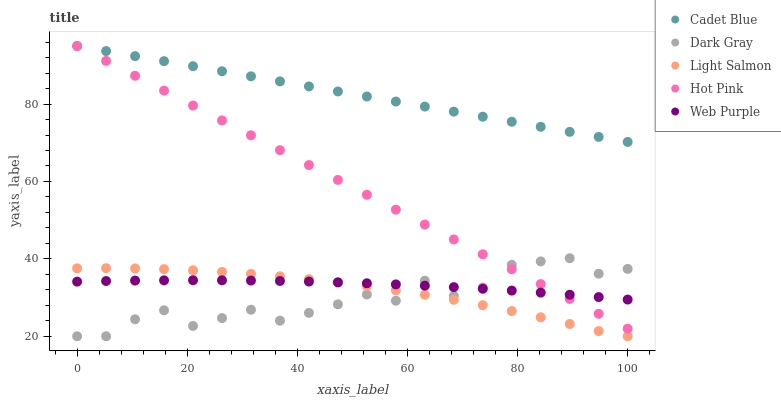Does Dark Gray have the minimum area under the curve?
Answer yes or no. Yes. Does Cadet Blue have the maximum area under the curve?
Answer yes or no. Yes. Does Light Salmon have the minimum area under the curve?
Answer yes or no. No. Does Light Salmon have the maximum area under the curve?
Answer yes or no. No. Is Hot Pink the smoothest?
Answer yes or no. Yes. Is Dark Gray the roughest?
Answer yes or no. Yes. Is Light Salmon the smoothest?
Answer yes or no. No. Is Light Salmon the roughest?
Answer yes or no. No. Does Dark Gray have the lowest value?
Answer yes or no. Yes. Does Cadet Blue have the lowest value?
Answer yes or no. No. Does Hot Pink have the highest value?
Answer yes or no. Yes. Does Light Salmon have the highest value?
Answer yes or no. No. Is Light Salmon less than Hot Pink?
Answer yes or no. Yes. Is Cadet Blue greater than Light Salmon?
Answer yes or no. Yes. Does Web Purple intersect Dark Gray?
Answer yes or no. Yes. Is Web Purple less than Dark Gray?
Answer yes or no. No. Is Web Purple greater than Dark Gray?
Answer yes or no. No. Does Light Salmon intersect Hot Pink?
Answer yes or no. No. 